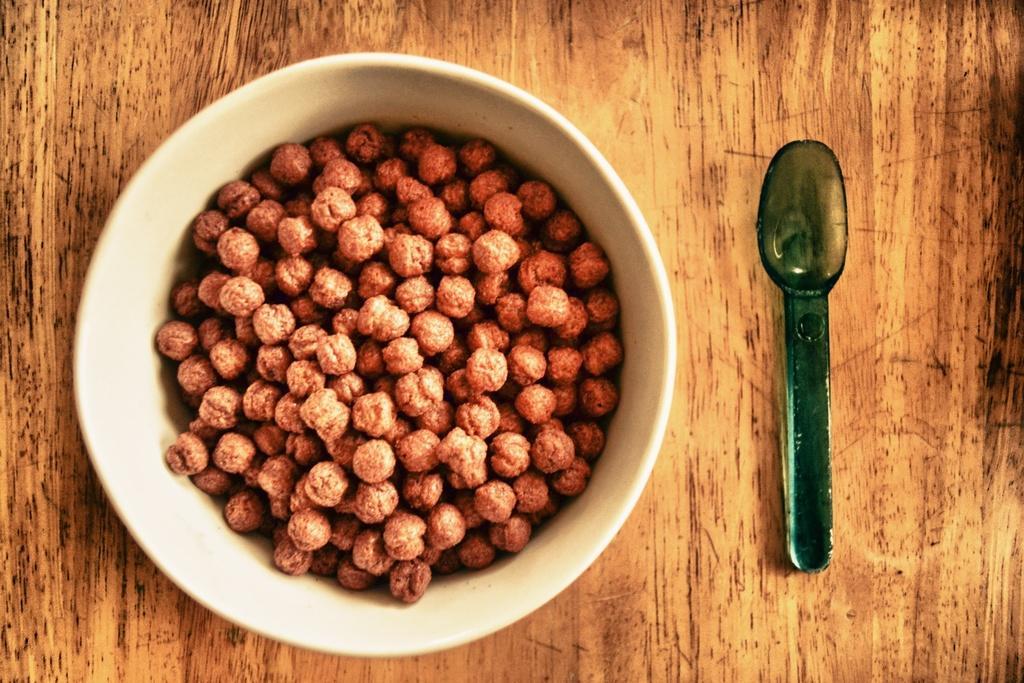Can you describe this image briefly? The picture consists of bowls, spoons. In the bowl there is a food item. The bowl and spoon are placed on a wooden object. 